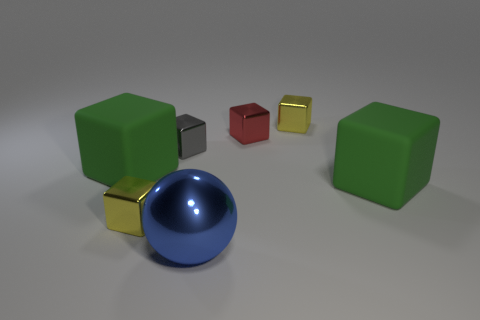Add 1 big blue spheres. How many objects exist? 8 Subtract 1 blue spheres. How many objects are left? 6 Subtract all balls. How many objects are left? 6 Subtract 1 spheres. How many spheres are left? 0 Subtract all yellow cubes. Subtract all purple cylinders. How many cubes are left? 4 Subtract all yellow cubes. How many green spheres are left? 0 Subtract all big yellow rubber cylinders. Subtract all blue shiny spheres. How many objects are left? 6 Add 2 metal objects. How many metal objects are left? 7 Add 4 big cubes. How many big cubes exist? 6 Subtract all yellow cubes. How many cubes are left? 4 